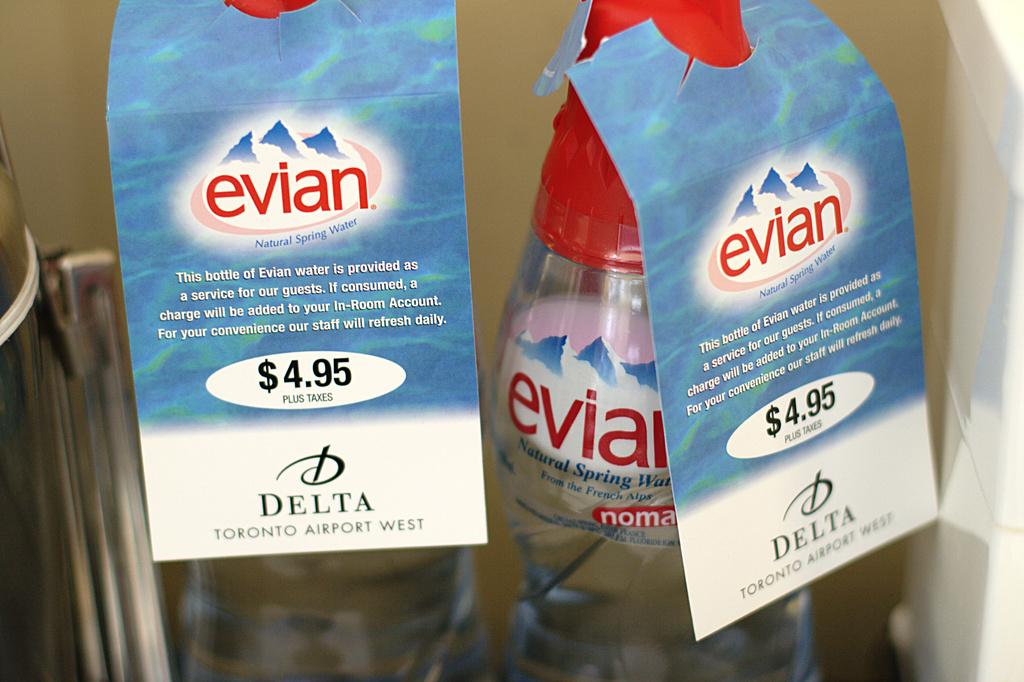<image>
Summarize the visual content of the image. A bottle of evian Natural Spring Water sold by Delta is $4.95. 